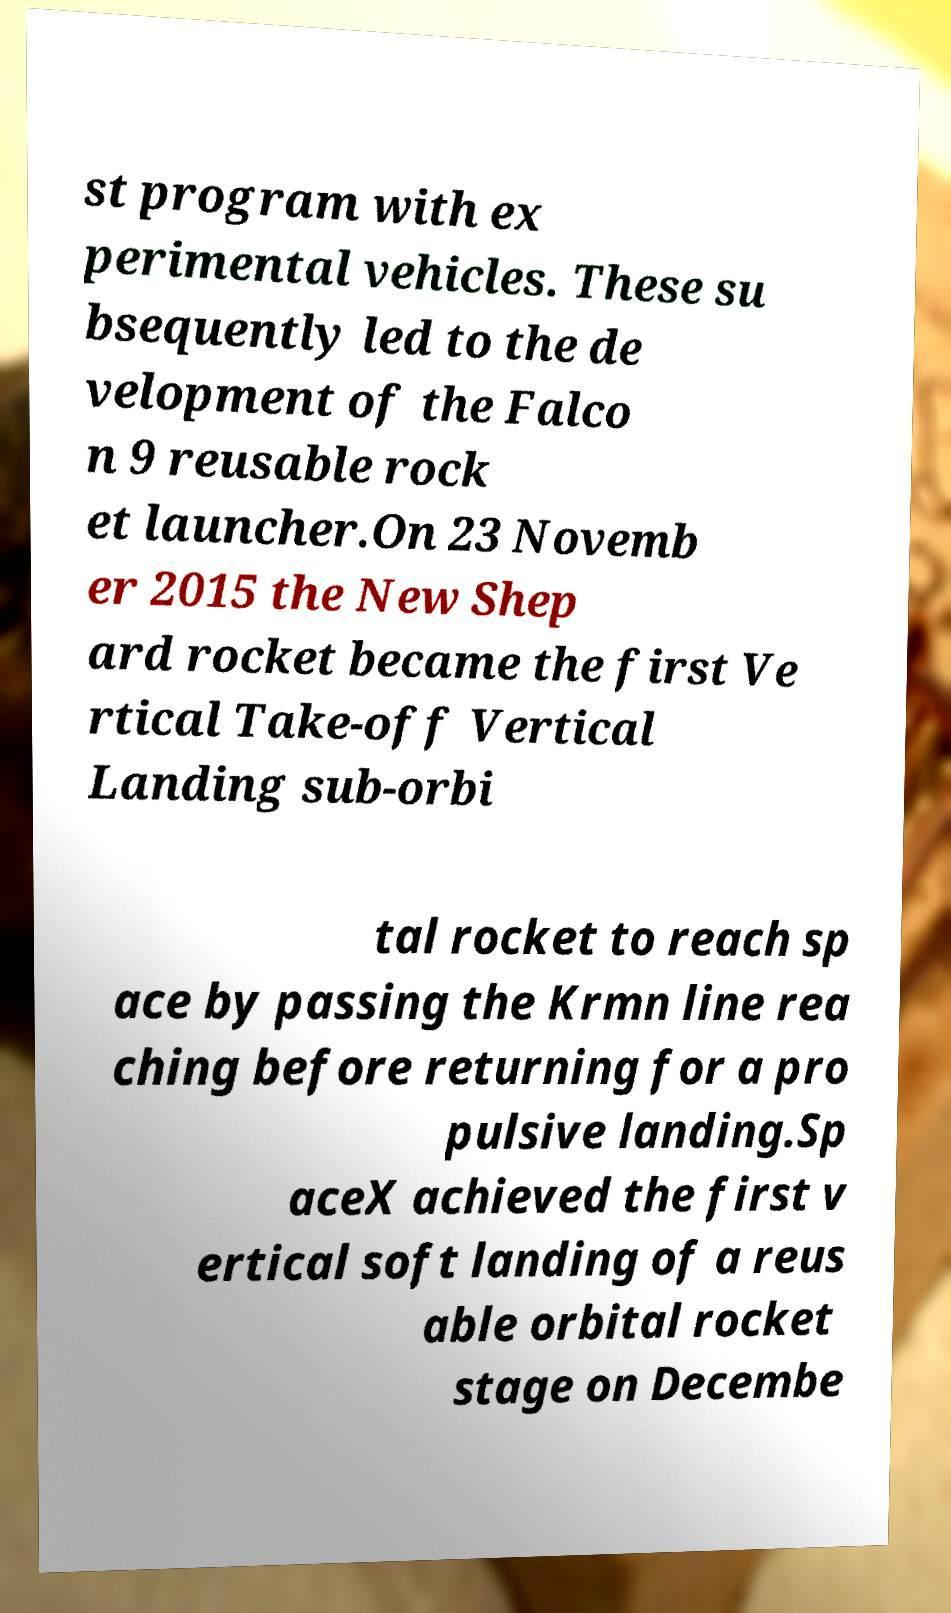For documentation purposes, I need the text within this image transcribed. Could you provide that? st program with ex perimental vehicles. These su bsequently led to the de velopment of the Falco n 9 reusable rock et launcher.On 23 Novemb er 2015 the New Shep ard rocket became the first Ve rtical Take-off Vertical Landing sub-orbi tal rocket to reach sp ace by passing the Krmn line rea ching before returning for a pro pulsive landing.Sp aceX achieved the first v ertical soft landing of a reus able orbital rocket stage on Decembe 